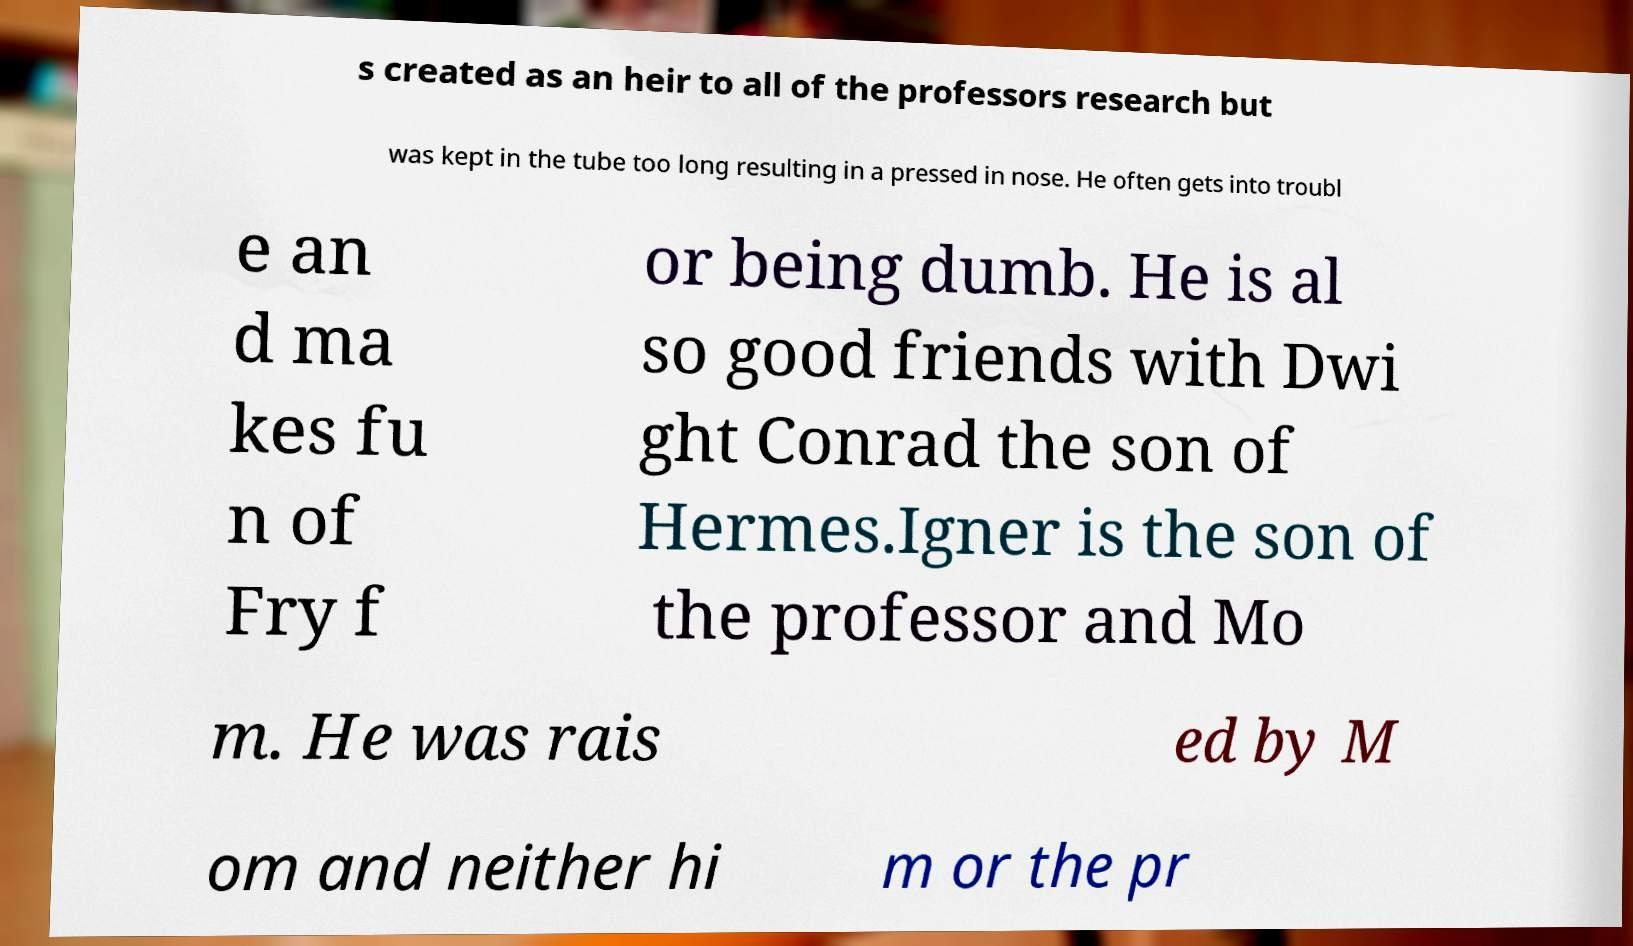For documentation purposes, I need the text within this image transcribed. Could you provide that? s created as an heir to all of the professors research but was kept in the tube too long resulting in a pressed in nose. He often gets into troubl e an d ma kes fu n of Fry f or being dumb. He is al so good friends with Dwi ght Conrad the son of Hermes.Igner is the son of the professor and Mo m. He was rais ed by M om and neither hi m or the pr 